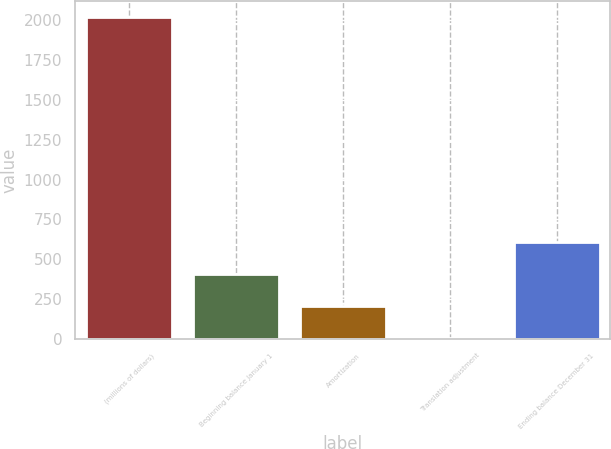Convert chart. <chart><loc_0><loc_0><loc_500><loc_500><bar_chart><fcel>(millions of dollars)<fcel>Beginning balance January 1<fcel>Amortization<fcel>Translation adjustment<fcel>Ending balance December 31<nl><fcel>2016<fcel>409.04<fcel>208.17<fcel>7.3<fcel>609.91<nl></chart> 